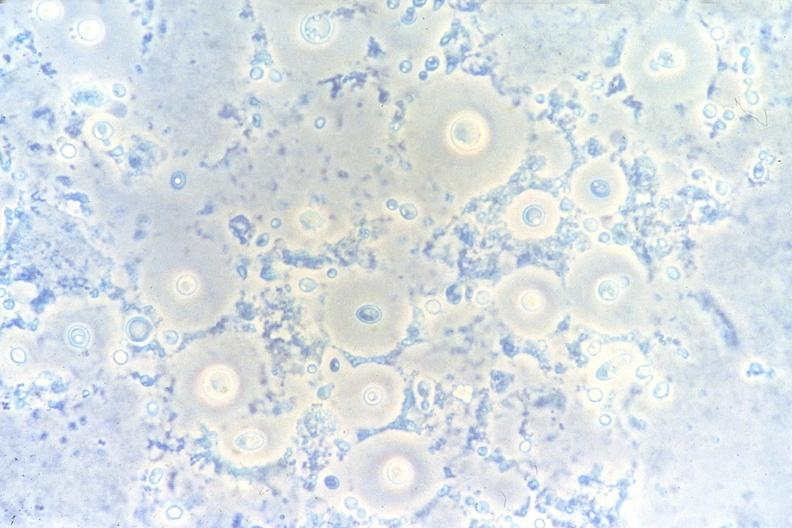does source show lung, cryptococcal pneumonia, touch impression under phase contract?
Answer the question using a single word or phrase. No 